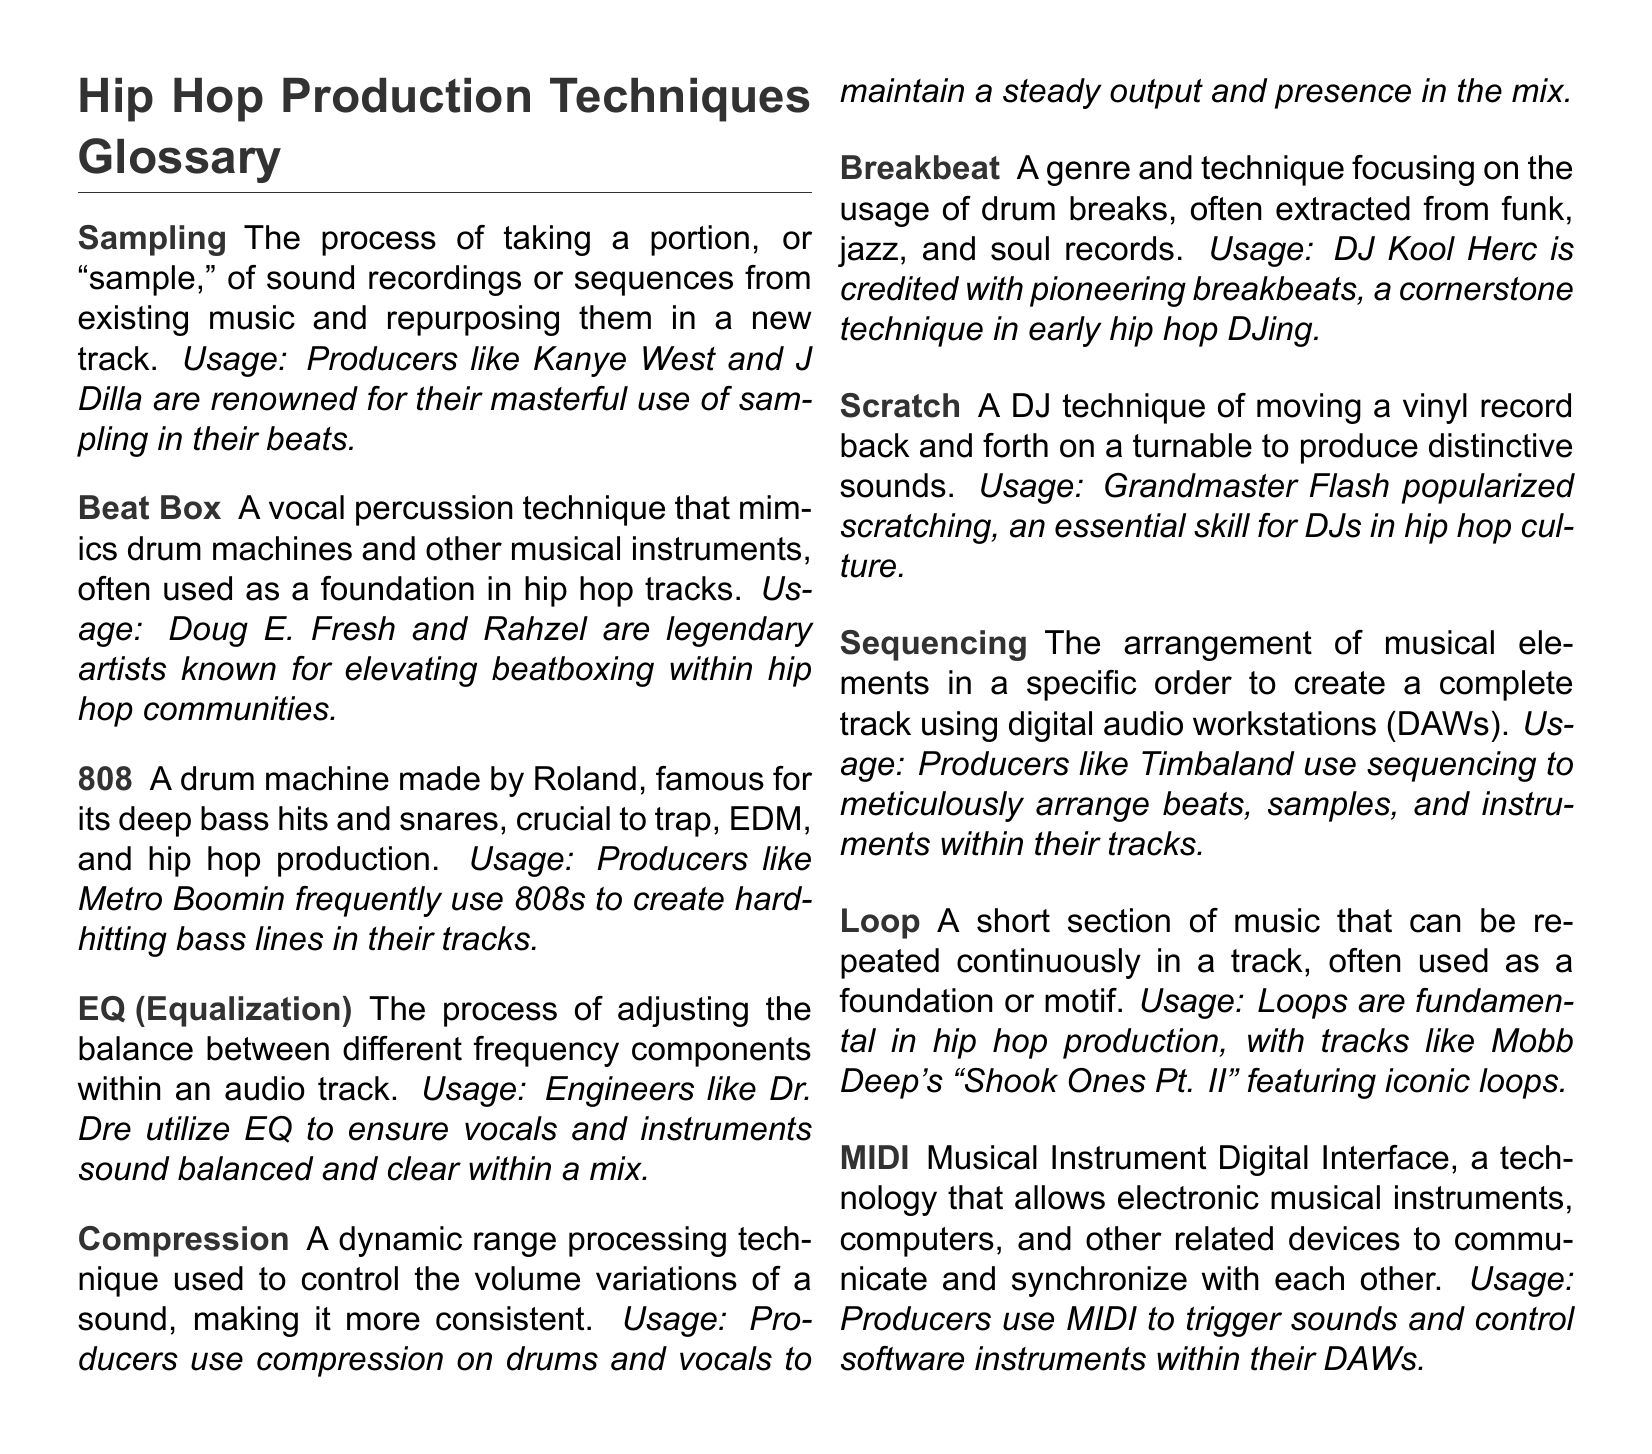What is sampling? Sampling is the process of taking a portion, or "sample," of sound recordings or sequences from existing music and repurposing them in a new track.
Answer: The process of taking a portion, or "sample," of sound recordings Who is known for masterful use of sampling? The document mentions producers known for their use of sampling, specifically Kanye West and J Dilla.
Answer: Kanye West and J Dilla What does 808 refer to in hip hop production? 808 refers to a drum machine made by Roland, famous for its deep bass hits and snares.
Answer: A drum machine made by Roland Which artist is credited with pioneering breakbeats? The document states that DJ Kool Herc is credited with pioneering breakbeats.
Answer: DJ Kool Herc What is the main purpose of compression in production? Compression is used to control the volume variations of a sound, making it more consistent.
Answer: To control volume variations What does MIDI stand for? The term MIDI is an acronym for Musical Instrument Digital Interface.
Answer: Musical Instrument Digital Interface How does sequencing relate to DAWs? Sequencing is the arrangement of musical elements in a specific order to create a complete track using digital audio workstations (DAWs).
Answer: Arrangement of musical elements in DAWs Who popularized scratching in hip hop culture? The document attributes the popularization of scratching to Grandmaster Flash.
Answer: Grandmaster Flash 